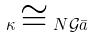Convert formula to latex. <formula><loc_0><loc_0><loc_500><loc_500>\kappa \cong N \mathcal { G } \bar { a }</formula> 